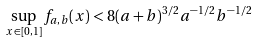Convert formula to latex. <formula><loc_0><loc_0><loc_500><loc_500>\sup _ { x \in [ 0 , 1 ] } f _ { a , b } ( x ) < 8 ( a + b ) ^ { 3 / 2 } a ^ { - 1 / 2 } b ^ { - 1 / 2 }</formula> 